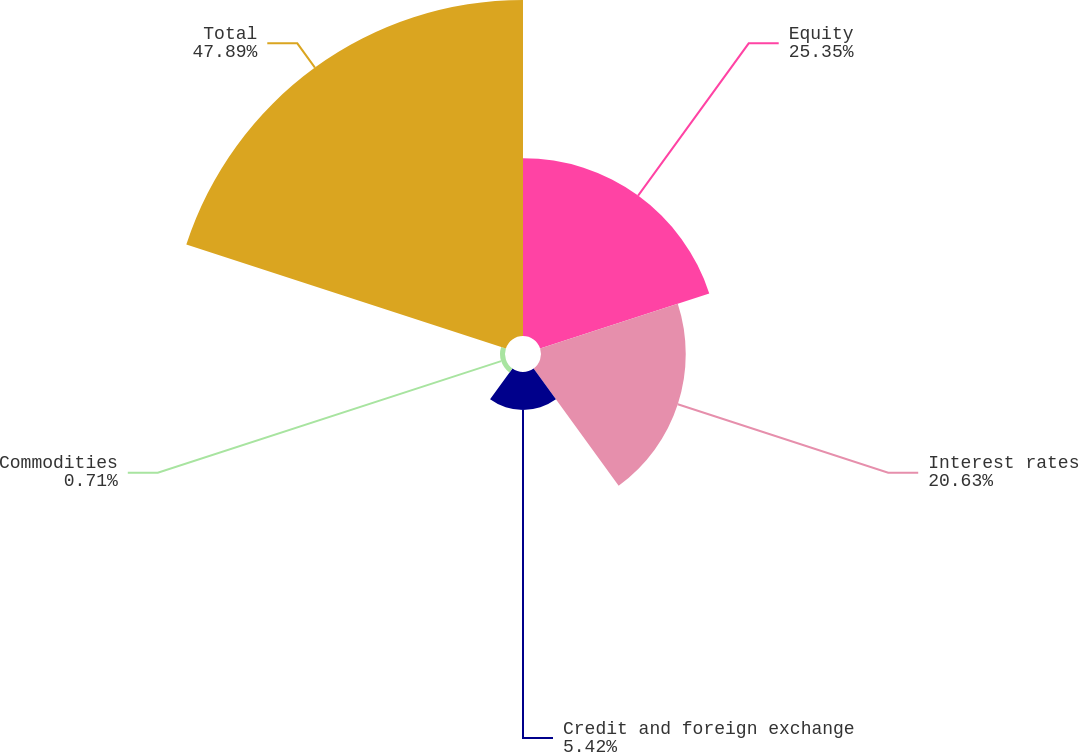Convert chart. <chart><loc_0><loc_0><loc_500><loc_500><pie_chart><fcel>Equity<fcel>Interest rates<fcel>Credit and foreign exchange<fcel>Commodities<fcel>Total<nl><fcel>25.35%<fcel>20.63%<fcel>5.42%<fcel>0.71%<fcel>47.89%<nl></chart> 